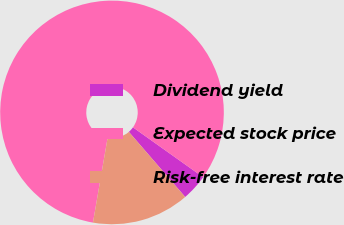Convert chart. <chart><loc_0><loc_0><loc_500><loc_500><pie_chart><fcel>Dividend yield<fcel>Expected stock price<fcel>Risk-free interest rate<nl><fcel>3.81%<fcel>82.11%<fcel>14.08%<nl></chart> 